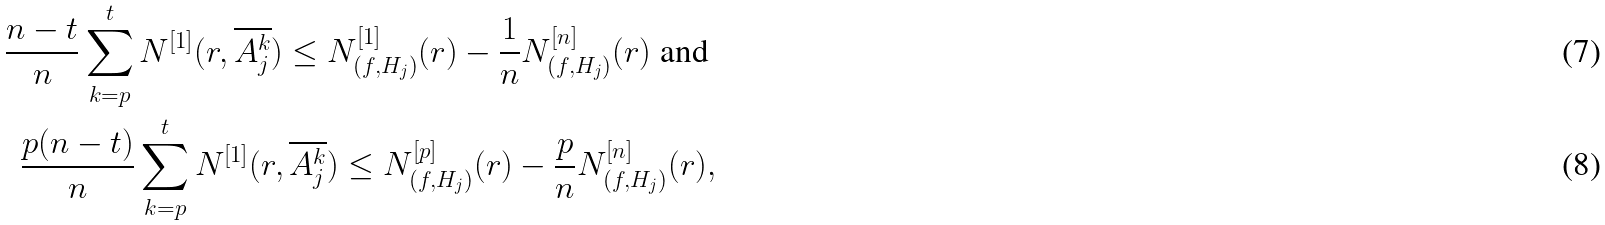Convert formula to latex. <formula><loc_0><loc_0><loc_500><loc_500>\frac { n - t } { n } \sum _ { k = p } ^ { t } N ^ { [ 1 ] } ( r , \overline { A _ { j } ^ { k } } ) \leq N _ { ( f , H _ { j } ) } ^ { [ 1 ] } ( r ) - \frac { 1 } { n } N _ { ( f , H _ { j } ) } ^ { [ n ] } ( r ) \text {\ and\ } \\ \frac { p ( n - t ) } { n } \sum _ { k = p } ^ { t } N ^ { [ 1 ] } ( r , \overline { A _ { j } ^ { k } } ) \leq N _ { ( f , H _ { j } ) } ^ { [ p ] } ( r ) - \frac { p } { n } N _ { ( f , H _ { j } ) } ^ { [ n ] } ( r ) ,</formula> 